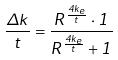Convert formula to latex. <formula><loc_0><loc_0><loc_500><loc_500>\frac { \Delta k } { t } = \frac { R ^ { \frac { 4 k _ { e } } { t } } \cdot 1 } { R ^ { \frac { 4 k _ { e } } { t } } + 1 }</formula> 